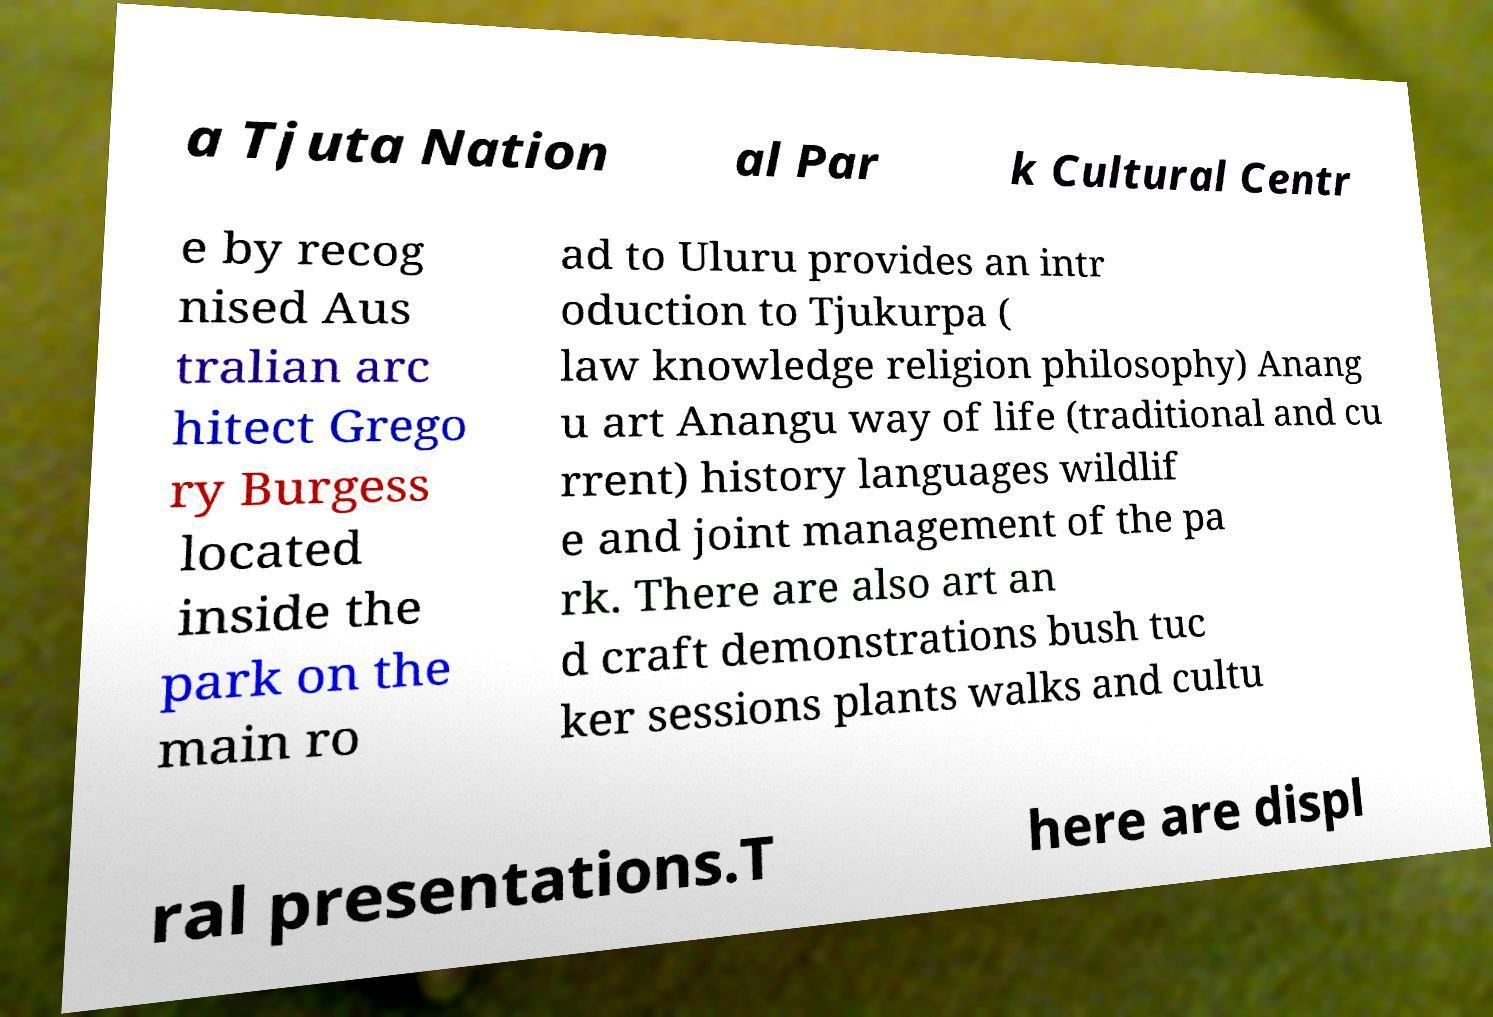There's text embedded in this image that I need extracted. Can you transcribe it verbatim? a Tjuta Nation al Par k Cultural Centr e by recog nised Aus tralian arc hitect Grego ry Burgess located inside the park on the main ro ad to Uluru provides an intr oduction to Tjukurpa ( law knowledge religion philosophy) Anang u art Anangu way of life (traditional and cu rrent) history languages wildlif e and joint management of the pa rk. There are also art an d craft demonstrations bush tuc ker sessions plants walks and cultu ral presentations.T here are displ 